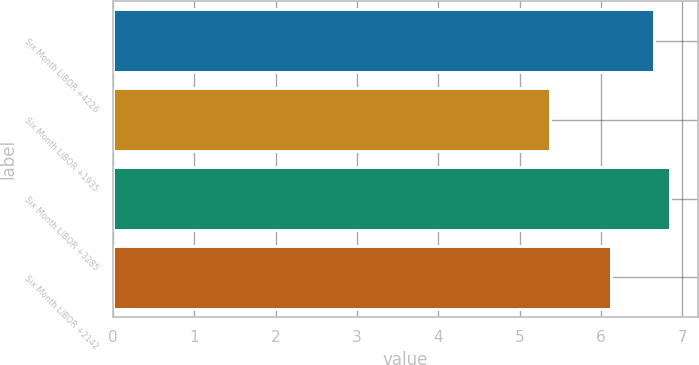<chart> <loc_0><loc_0><loc_500><loc_500><bar_chart><fcel>Six Month LIBOR +4226<fcel>Six Month LIBOR +1935<fcel>Six Month LIBOR +3285<fcel>Six Month LIBOR +2142<nl><fcel>6.65<fcel>5.38<fcel>6.85<fcel>6.12<nl></chart> 